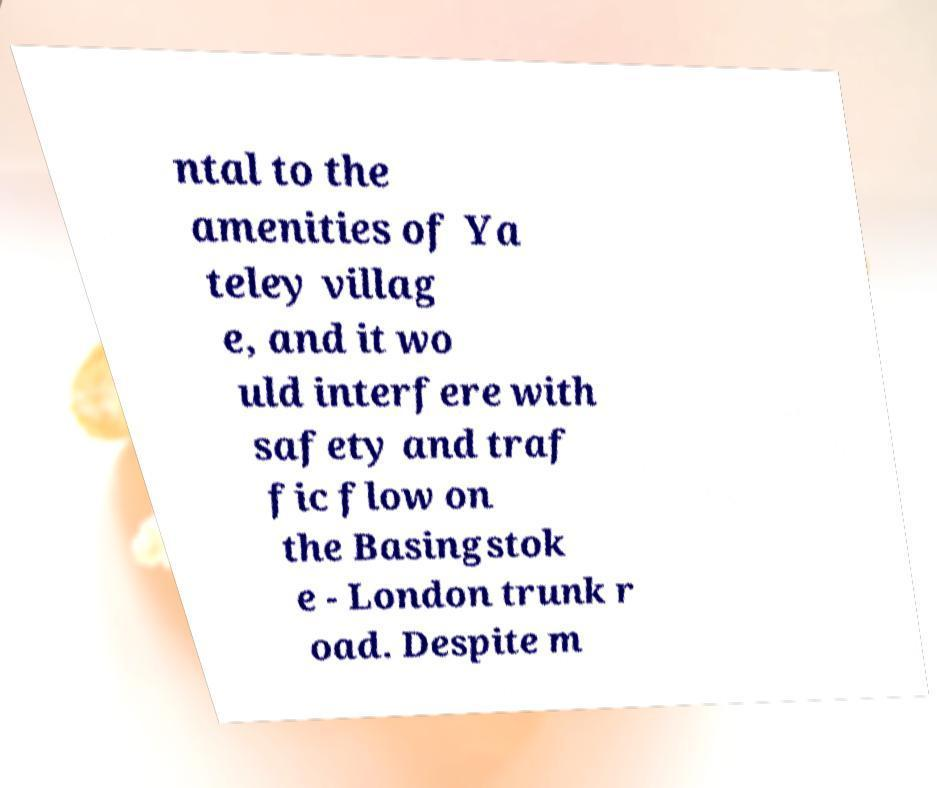Can you accurately transcribe the text from the provided image for me? ntal to the amenities of Ya teley villag e, and it wo uld interfere with safety and traf fic flow on the Basingstok e - London trunk r oad. Despite m 